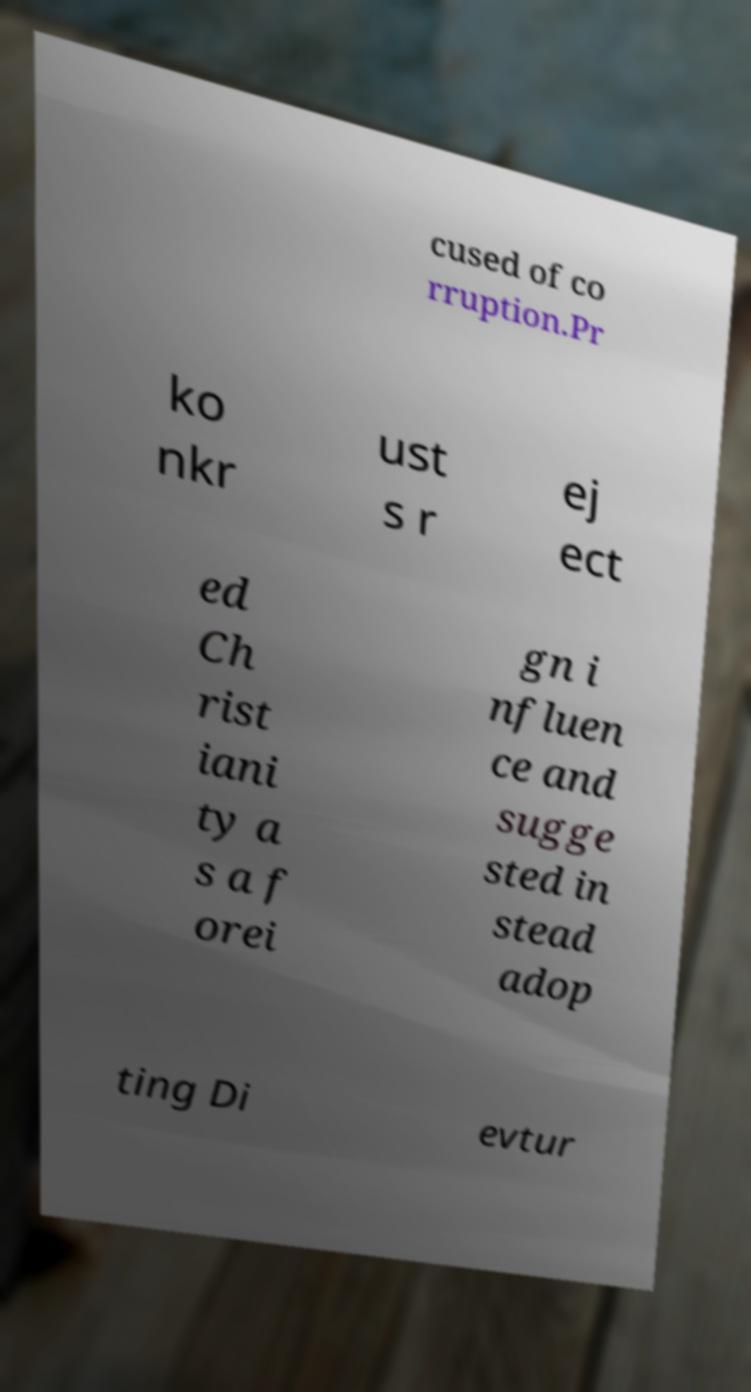Please identify and transcribe the text found in this image. cused of co rruption.Pr ko nkr ust s r ej ect ed Ch rist iani ty a s a f orei gn i nfluen ce and sugge sted in stead adop ting Di evtur 